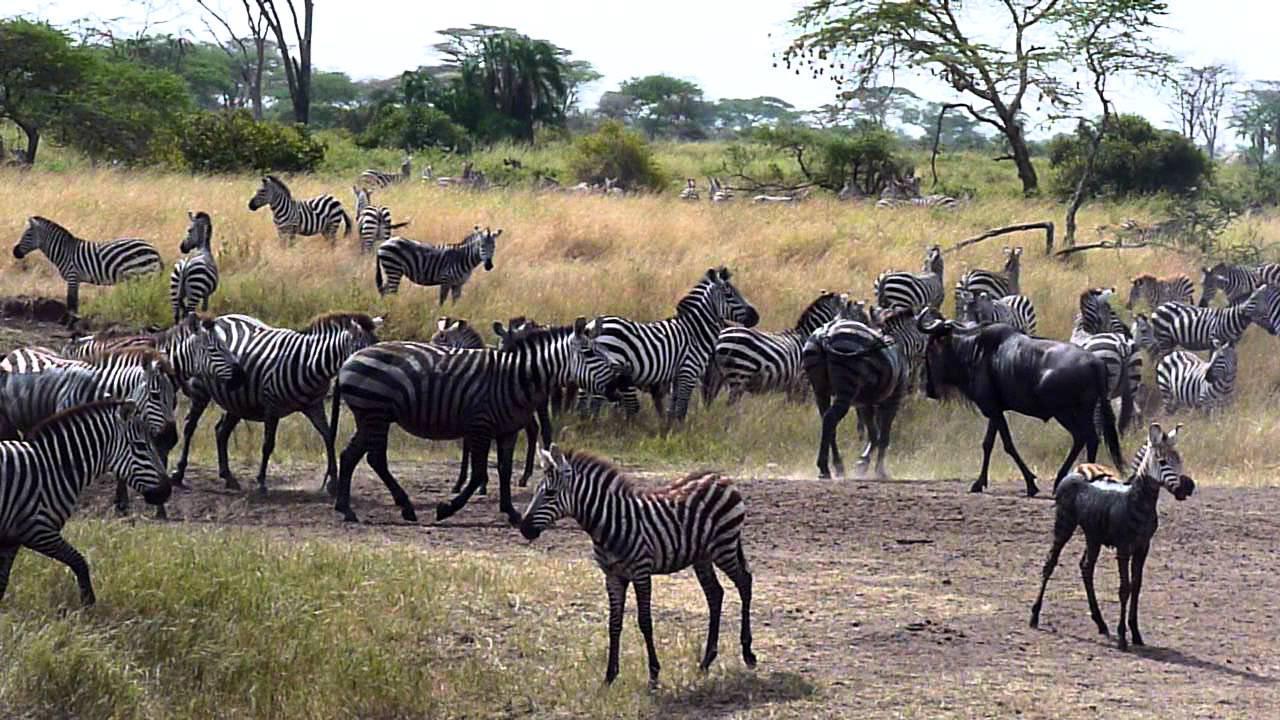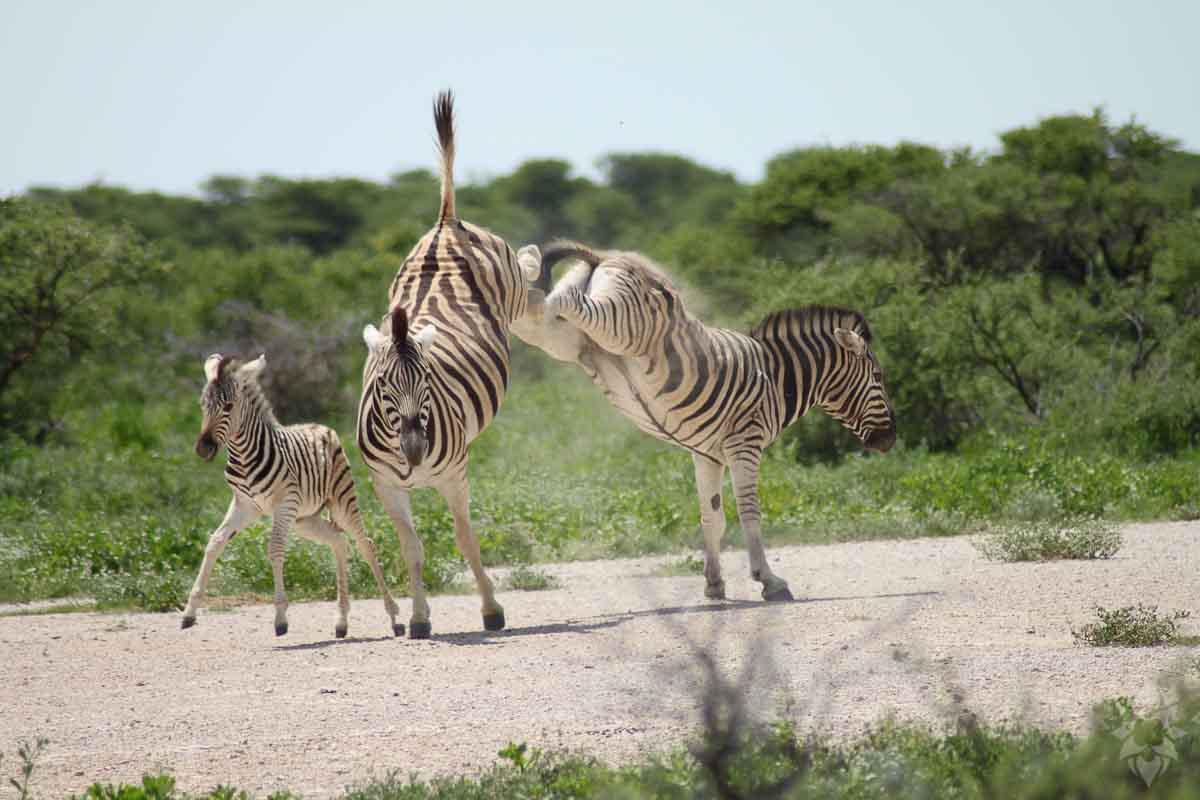The first image is the image on the left, the second image is the image on the right. For the images displayed, is the sentence "The left image shows a young zebra bounding leftward, with multiple feet off the ground, and the right image features two zebras fact-to-face." factually correct? Answer yes or no. No. The first image is the image on the left, the second image is the image on the right. For the images shown, is this caption "One of the animals in the image on the right only has two feet on the ground." true? Answer yes or no. Yes. 